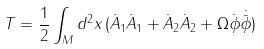<formula> <loc_0><loc_0><loc_500><loc_500>T = \frac { 1 } { 2 } \int _ { M } d ^ { 2 } x \, ( \dot { A } _ { 1 } \dot { A } _ { 1 } + \dot { A } _ { 2 } \dot { A } _ { 2 } + \Omega \dot { \phi } \dot { { \bar { \phi } } } )</formula> 